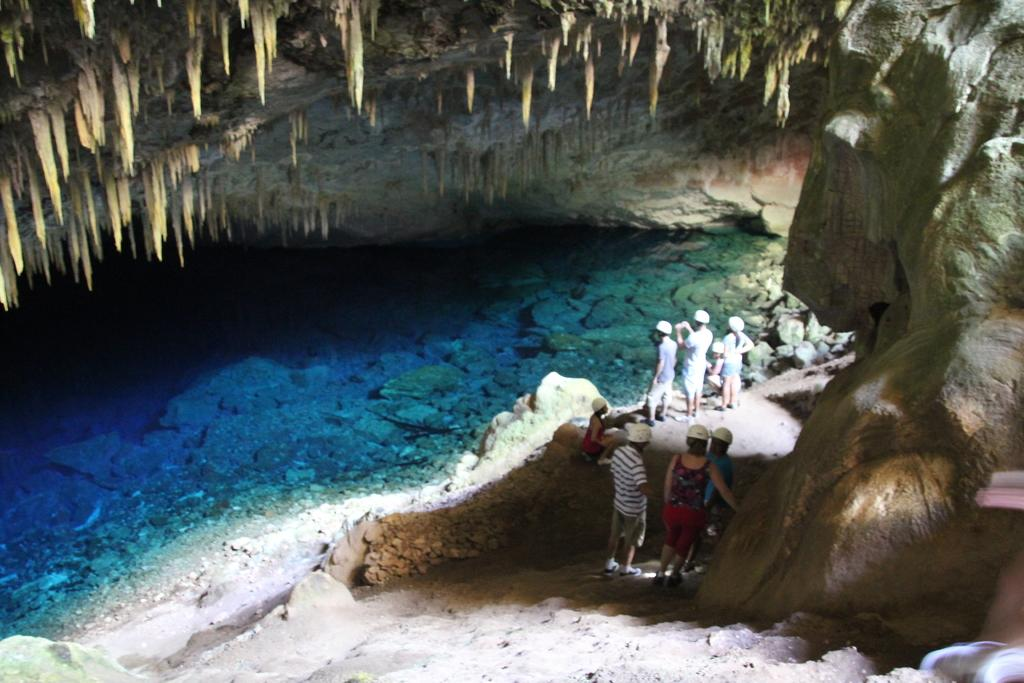How many people are in the image? There is a group of people in the image. What are the people wearing on their heads? The people are wearing helmets. What is the terrain like in the image? The people are standing on rocks. What natural element is present in the image? Water is visible in the image. Can you see a cactus growing near the people in the image? There is no cactus visible in the image. What advice might the people's grandmother give them in the image? There is no grandmother present in the image, so it is not possible to determine what advice she might give. 